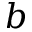<formula> <loc_0><loc_0><loc_500><loc_500>b</formula> 